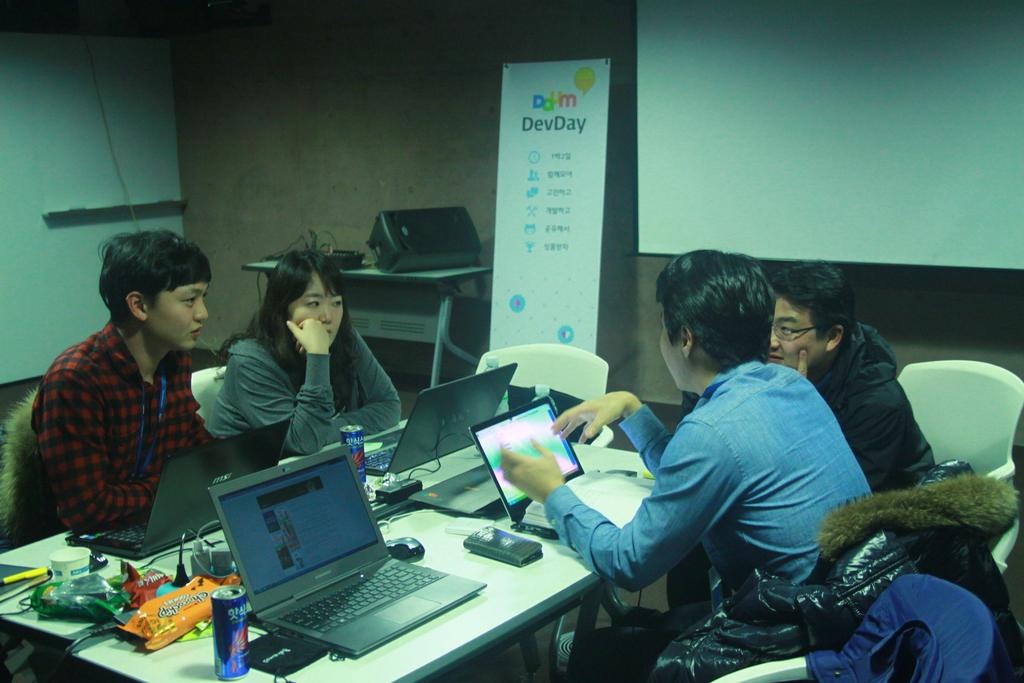Provide a one-sentence caption for the provided image. Four people have a conversation in front of a sign that says DevDay. 